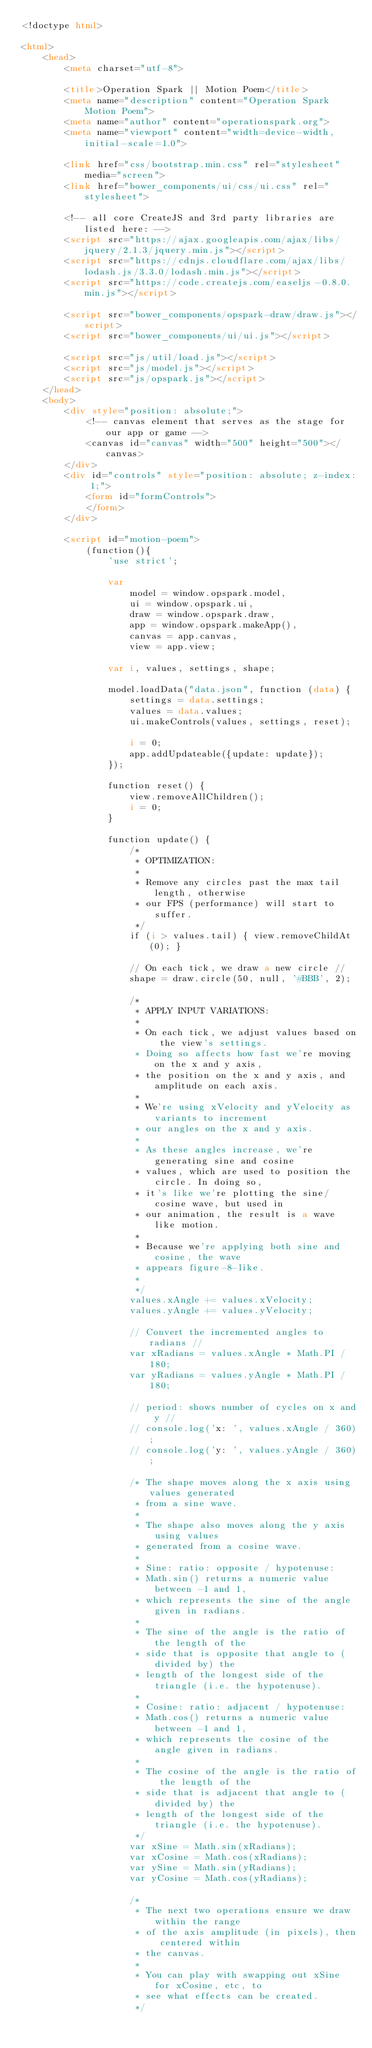Convert code to text. <code><loc_0><loc_0><loc_500><loc_500><_HTML_><!doctype html>

<html>
    <head>
        <meta charset="utf-8">

        <title>Operation Spark || Motion Poem</title>
        <meta name="description" content="Operation Spark Motion Poem">
        <meta name="author" content="operationspark.org">
        <meta name="viewport" content="width=device-width, initial-scale=1.0">
        
        <link href="css/bootstrap.min.css" rel="stylesheet" media="screen">
        <link href="bower_components/ui/css/ui.css" rel="stylesheet">

        <!-- all core CreateJS and 3rd party libraries are listed here: -->
        <script src="https://ajax.googleapis.com/ajax/libs/jquery/2.1.3/jquery.min.js"></script>
        <script src="https://cdnjs.cloudflare.com/ajax/libs/lodash.js/3.3.0/lodash.min.js"></script>
        <script src="https://code.createjs.com/easeljs-0.8.0.min.js"></script>
        
        <script src="bower_components/opspark-draw/draw.js"></script>
        <script src="bower_components/ui/ui.js"></script>
        
        <script src="js/util/load.js"></script>
        <script src="js/model.js"></script>
        <script src="js/opspark.js"></script>
    </head>
    <body>
        <div style="position: absolute;">
            <!-- canvas element that serves as the stage for our app or game -->
            <canvas id="canvas" width="500" height="500"></canvas>
        </div>
        <div id="controls" style="position: absolute; z-index: 1;">
            <form id="formControls">
            </form>
        </div>
        
        <script id="motion-poem">
            (function(){
                'use strict';
                
                var 
                    model = window.opspark.model,
                    ui = window.opspark.ui,
                    draw = window.opspark.draw,
                    app = window.opspark.makeApp(),
                    canvas = app.canvas, 
                    view = app.view;
                
                var i, values, settings, shape;
                
                model.loadData("data.json", function (data) {
                    settings = data.settings;
                    values = data.values;
                    ui.makeControls(values, settings, reset);
                    
                    i = 0;
                    app.addUpdateable({update: update});
                });
                
                function reset() {
                    view.removeAllChildren();
                    i = 0;
                }
                
                function update() {
                    /*
                     * OPTIMIZATION:
                     *
                     * Remove any circles past the max tail length, otherwise
                     * our FPS (performance) will start to suffer.
                     */
                    if (i > values.tail) { view.removeChildAt(0); }
                    
                    // On each tick, we draw a new circle //
                    shape = draw.circle(50, null, '#BBB', 2);
                    
                    /* 
                     * APPLY INPUT VARIATIONS:
                     *
                     * On each tick, we adjust values based on the view's settings.
                     * Doing so affects how fast we're moving on the x and y axis, 
                     * the position on the x and y axis, and amplitude on each axis.
                     *
                     * We're using xVelocity and yVelocity as variants to increment 
                     * our angles on the x and y axis.
                     * 
                     * As these angles increase, we're generating sine and cosine 
                     * values, which are used to position the circle. In doing so, 
                     * it's like we're plotting the sine/cosine wave, but used in 
                     * our animation, the result is a wave like motion.
                     *
                     * Because we're applying both sine and cosine, the wave 
                     * appears figure-8-like.
                     *
                     */
                    values.xAngle += values.xVelocity;
                    values.yAngle += values.yVelocity;
                    
                    // Convert the incremented angles to radians //
                    var xRadians = values.xAngle * Math.PI / 180;
                    var yRadians = values.yAngle * Math.PI / 180;
                    
                    // period: shows number of cycles on x and y //
                    // console.log('x: ', values.xAngle / 360);
                    // console.log('y: ', values.yAngle / 360);
                    
                    /* The shape moves along the x axis using values generated 
                     * from a sine wave.
                     * 
                     * The shape also moves along the y axis using values 
                     * generated from a cosine wave.
                     * 
                     * Sine: ratio: opposite / hypotenuse:
                     * Math.sin() returns a numeric value between -1 and 1, 
                     * which represents the sine of the angle given in radians.
                     * 
                     * The sine of the angle is the ratio of the length of the 
                     * side that is opposite that angle to (divided by) the 
                     * length of the longest side of the triangle (i.e. the hypotenuse).
                     * 
                     * Cosine: ratio: adjacent / hypotenuse:
                     * Math.cos() returns a numeric value between -1 and 1, 
                     * which represents the cosine of the angle given in radians.
                     *
                     * The cosine of the angle is the ratio of the length of the 
                     * side that is adjacent that angle to (divided by) the 
                     * length of the longest side of the triangle (i.e. the hypotenuse).
                     */
                    var xSine = Math.sin(xRadians);
                    var xCosine = Math.cos(xRadians);
                    var ySine = Math.sin(yRadians);
                    var yCosine = Math.cos(yRadians);
                    
                    /*
                     * The next two operations ensure we draw within the range 
                     * of the axis amplitude (in pixels), then centered within 
                     * the canvas.
                     *
                     * You can play with swapping out xSine for xCosine, etc, to
                     * see what effects can be created.
                     */</code> 